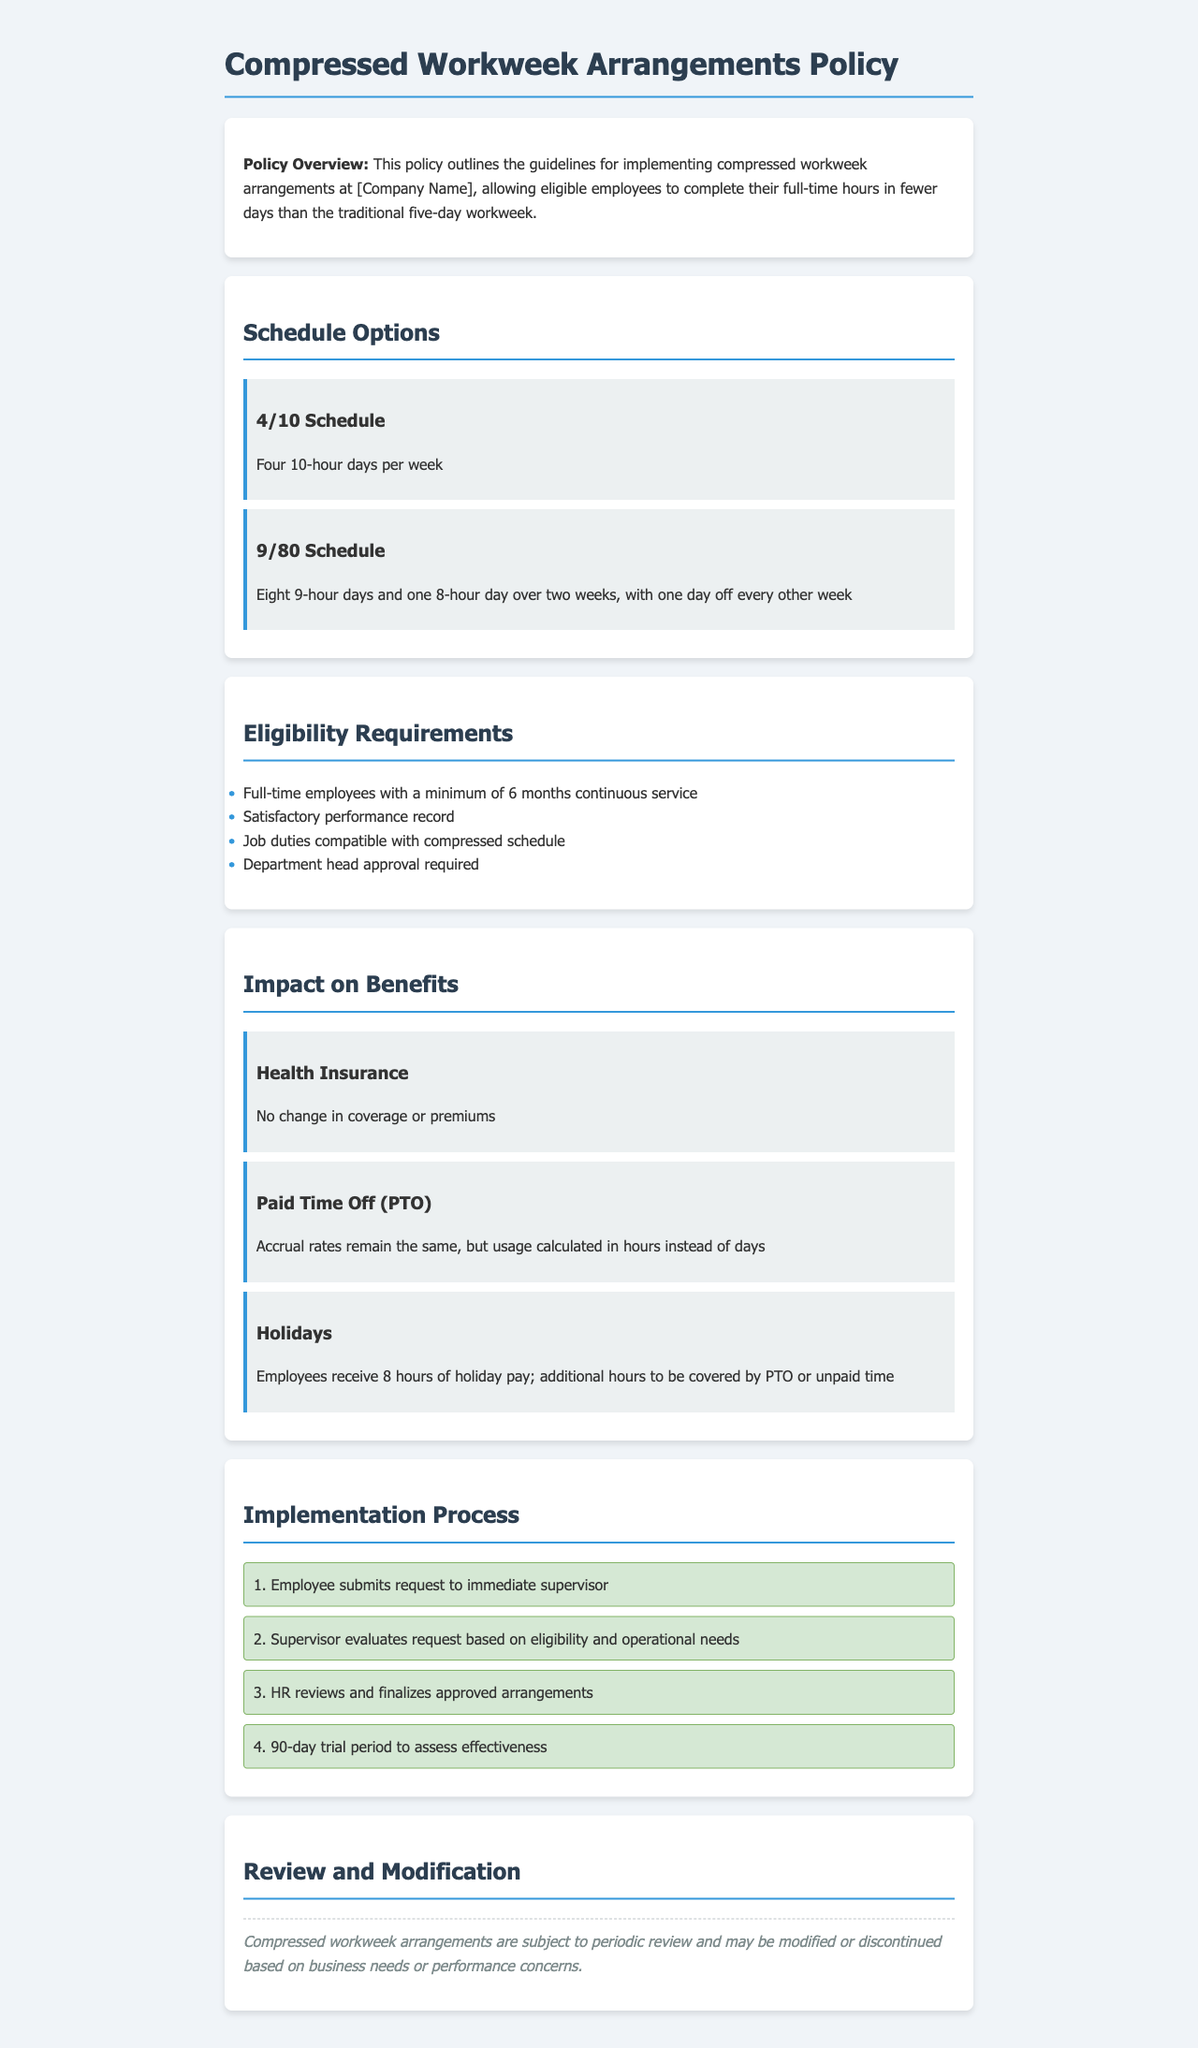What is the 4/10 schedule? The 4/10 schedule allows employees to work four 10-hour days per week.
Answer: Four 10-hour days per week What is required for eligibility? Employees must meet specific criteria such as continuous service and performance.
Answer: Minimum of 6 months continuous service How many holiday hours do employees receive? The document specifies the number of holiday hours provided to employees.
Answer: 8 hours What is the approval needed for the compressed workweek? The process requires a specific type of approval before proceeding with the request.
Answer: Department head approval How long is the trial period for the compressed workweek arrangements? The document states a specific timeframe for evaluating the arrangements.
Answer: 90-day trial period What is the impact on health insurance? Information regarding changes or stability in health insurance coverage is mentioned.
Answer: No change in coverage or premiums What needs to be assessed in the implementation process? The evaluation focuses on two critical aspects during the review of requests.
Answer: Eligibility and operational needs What is the PTO calculation method under the compressed workweek? The document mentions how PTO is calculated considering the new work arrangement.
Answer: Usage calculated in hours instead of days 